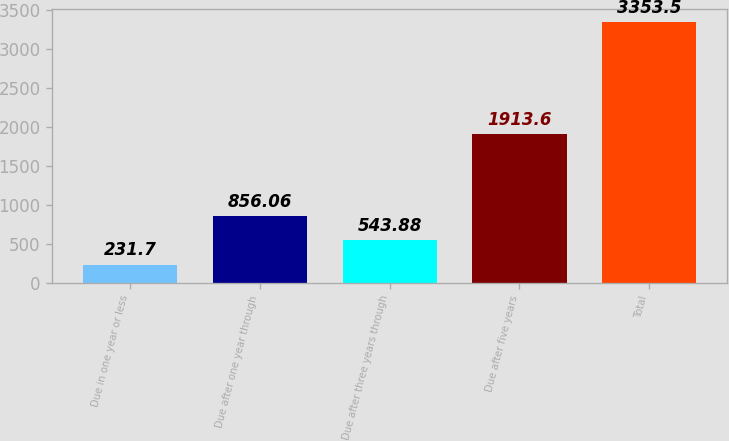Convert chart. <chart><loc_0><loc_0><loc_500><loc_500><bar_chart><fcel>Due in one year or less<fcel>Due after one year through<fcel>Due after three years through<fcel>Due after five years<fcel>Total<nl><fcel>231.7<fcel>856.06<fcel>543.88<fcel>1913.6<fcel>3353.5<nl></chart> 